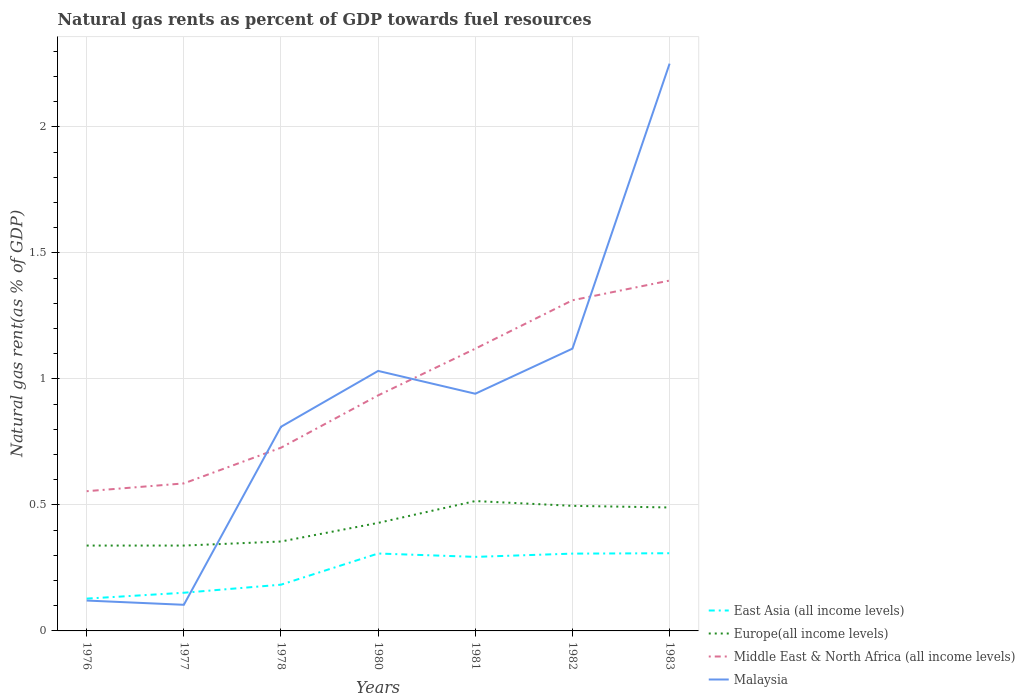Across all years, what is the maximum natural gas rent in East Asia (all income levels)?
Keep it short and to the point. 0.13. What is the total natural gas rent in Europe(all income levels) in the graph?
Ensure brevity in your answer.  0.03. What is the difference between the highest and the second highest natural gas rent in Malaysia?
Ensure brevity in your answer.  2.15. How many years are there in the graph?
Make the answer very short. 7. What is the difference between two consecutive major ticks on the Y-axis?
Keep it short and to the point. 0.5. Where does the legend appear in the graph?
Offer a very short reply. Bottom right. How many legend labels are there?
Your answer should be very brief. 4. How are the legend labels stacked?
Your answer should be compact. Vertical. What is the title of the graph?
Provide a succinct answer. Natural gas rents as percent of GDP towards fuel resources. What is the label or title of the X-axis?
Provide a succinct answer. Years. What is the label or title of the Y-axis?
Provide a short and direct response. Natural gas rent(as % of GDP). What is the Natural gas rent(as % of GDP) of East Asia (all income levels) in 1976?
Your answer should be very brief. 0.13. What is the Natural gas rent(as % of GDP) in Europe(all income levels) in 1976?
Your response must be concise. 0.34. What is the Natural gas rent(as % of GDP) of Middle East & North Africa (all income levels) in 1976?
Offer a very short reply. 0.55. What is the Natural gas rent(as % of GDP) in Malaysia in 1976?
Offer a very short reply. 0.12. What is the Natural gas rent(as % of GDP) in East Asia (all income levels) in 1977?
Your answer should be compact. 0.15. What is the Natural gas rent(as % of GDP) of Europe(all income levels) in 1977?
Give a very brief answer. 0.34. What is the Natural gas rent(as % of GDP) in Middle East & North Africa (all income levels) in 1977?
Your answer should be very brief. 0.59. What is the Natural gas rent(as % of GDP) of Malaysia in 1977?
Offer a very short reply. 0.1. What is the Natural gas rent(as % of GDP) in East Asia (all income levels) in 1978?
Offer a very short reply. 0.18. What is the Natural gas rent(as % of GDP) in Europe(all income levels) in 1978?
Your answer should be compact. 0.35. What is the Natural gas rent(as % of GDP) in Middle East & North Africa (all income levels) in 1978?
Provide a succinct answer. 0.73. What is the Natural gas rent(as % of GDP) in Malaysia in 1978?
Your answer should be compact. 0.81. What is the Natural gas rent(as % of GDP) in East Asia (all income levels) in 1980?
Your response must be concise. 0.31. What is the Natural gas rent(as % of GDP) of Europe(all income levels) in 1980?
Give a very brief answer. 0.43. What is the Natural gas rent(as % of GDP) in Middle East & North Africa (all income levels) in 1980?
Make the answer very short. 0.93. What is the Natural gas rent(as % of GDP) of Malaysia in 1980?
Give a very brief answer. 1.03. What is the Natural gas rent(as % of GDP) in East Asia (all income levels) in 1981?
Ensure brevity in your answer.  0.29. What is the Natural gas rent(as % of GDP) in Europe(all income levels) in 1981?
Your answer should be compact. 0.52. What is the Natural gas rent(as % of GDP) of Middle East & North Africa (all income levels) in 1981?
Your answer should be compact. 1.12. What is the Natural gas rent(as % of GDP) of Malaysia in 1981?
Offer a terse response. 0.94. What is the Natural gas rent(as % of GDP) of East Asia (all income levels) in 1982?
Ensure brevity in your answer.  0.31. What is the Natural gas rent(as % of GDP) of Europe(all income levels) in 1982?
Offer a very short reply. 0.5. What is the Natural gas rent(as % of GDP) in Middle East & North Africa (all income levels) in 1982?
Offer a terse response. 1.31. What is the Natural gas rent(as % of GDP) in Malaysia in 1982?
Your answer should be compact. 1.12. What is the Natural gas rent(as % of GDP) in East Asia (all income levels) in 1983?
Give a very brief answer. 0.31. What is the Natural gas rent(as % of GDP) in Europe(all income levels) in 1983?
Offer a very short reply. 0.49. What is the Natural gas rent(as % of GDP) in Middle East & North Africa (all income levels) in 1983?
Offer a very short reply. 1.39. What is the Natural gas rent(as % of GDP) of Malaysia in 1983?
Provide a short and direct response. 2.25. Across all years, what is the maximum Natural gas rent(as % of GDP) of East Asia (all income levels)?
Keep it short and to the point. 0.31. Across all years, what is the maximum Natural gas rent(as % of GDP) in Europe(all income levels)?
Offer a very short reply. 0.52. Across all years, what is the maximum Natural gas rent(as % of GDP) of Middle East & North Africa (all income levels)?
Provide a short and direct response. 1.39. Across all years, what is the maximum Natural gas rent(as % of GDP) of Malaysia?
Ensure brevity in your answer.  2.25. Across all years, what is the minimum Natural gas rent(as % of GDP) of East Asia (all income levels)?
Give a very brief answer. 0.13. Across all years, what is the minimum Natural gas rent(as % of GDP) in Europe(all income levels)?
Your answer should be very brief. 0.34. Across all years, what is the minimum Natural gas rent(as % of GDP) of Middle East & North Africa (all income levels)?
Offer a very short reply. 0.55. Across all years, what is the minimum Natural gas rent(as % of GDP) in Malaysia?
Offer a very short reply. 0.1. What is the total Natural gas rent(as % of GDP) of East Asia (all income levels) in the graph?
Give a very brief answer. 1.68. What is the total Natural gas rent(as % of GDP) of Europe(all income levels) in the graph?
Provide a short and direct response. 2.96. What is the total Natural gas rent(as % of GDP) in Middle East & North Africa (all income levels) in the graph?
Your answer should be very brief. 6.62. What is the total Natural gas rent(as % of GDP) in Malaysia in the graph?
Give a very brief answer. 6.38. What is the difference between the Natural gas rent(as % of GDP) of East Asia (all income levels) in 1976 and that in 1977?
Give a very brief answer. -0.02. What is the difference between the Natural gas rent(as % of GDP) in Europe(all income levels) in 1976 and that in 1977?
Provide a succinct answer. -0. What is the difference between the Natural gas rent(as % of GDP) in Middle East & North Africa (all income levels) in 1976 and that in 1977?
Provide a succinct answer. -0.03. What is the difference between the Natural gas rent(as % of GDP) of Malaysia in 1976 and that in 1977?
Offer a very short reply. 0.02. What is the difference between the Natural gas rent(as % of GDP) in East Asia (all income levels) in 1976 and that in 1978?
Provide a short and direct response. -0.06. What is the difference between the Natural gas rent(as % of GDP) of Europe(all income levels) in 1976 and that in 1978?
Give a very brief answer. -0.02. What is the difference between the Natural gas rent(as % of GDP) in Middle East & North Africa (all income levels) in 1976 and that in 1978?
Your answer should be compact. -0.17. What is the difference between the Natural gas rent(as % of GDP) of Malaysia in 1976 and that in 1978?
Give a very brief answer. -0.69. What is the difference between the Natural gas rent(as % of GDP) in East Asia (all income levels) in 1976 and that in 1980?
Make the answer very short. -0.18. What is the difference between the Natural gas rent(as % of GDP) of Europe(all income levels) in 1976 and that in 1980?
Keep it short and to the point. -0.09. What is the difference between the Natural gas rent(as % of GDP) of Middle East & North Africa (all income levels) in 1976 and that in 1980?
Provide a short and direct response. -0.38. What is the difference between the Natural gas rent(as % of GDP) in Malaysia in 1976 and that in 1980?
Offer a terse response. -0.91. What is the difference between the Natural gas rent(as % of GDP) of East Asia (all income levels) in 1976 and that in 1981?
Make the answer very short. -0.17. What is the difference between the Natural gas rent(as % of GDP) of Europe(all income levels) in 1976 and that in 1981?
Ensure brevity in your answer.  -0.18. What is the difference between the Natural gas rent(as % of GDP) of Middle East & North Africa (all income levels) in 1976 and that in 1981?
Give a very brief answer. -0.57. What is the difference between the Natural gas rent(as % of GDP) in Malaysia in 1976 and that in 1981?
Your response must be concise. -0.82. What is the difference between the Natural gas rent(as % of GDP) in East Asia (all income levels) in 1976 and that in 1982?
Make the answer very short. -0.18. What is the difference between the Natural gas rent(as % of GDP) of Europe(all income levels) in 1976 and that in 1982?
Offer a terse response. -0.16. What is the difference between the Natural gas rent(as % of GDP) in Middle East & North Africa (all income levels) in 1976 and that in 1982?
Make the answer very short. -0.76. What is the difference between the Natural gas rent(as % of GDP) of Malaysia in 1976 and that in 1982?
Provide a succinct answer. -1. What is the difference between the Natural gas rent(as % of GDP) in East Asia (all income levels) in 1976 and that in 1983?
Your answer should be compact. -0.18. What is the difference between the Natural gas rent(as % of GDP) of Europe(all income levels) in 1976 and that in 1983?
Your answer should be very brief. -0.15. What is the difference between the Natural gas rent(as % of GDP) in Middle East & North Africa (all income levels) in 1976 and that in 1983?
Provide a succinct answer. -0.84. What is the difference between the Natural gas rent(as % of GDP) of Malaysia in 1976 and that in 1983?
Provide a short and direct response. -2.13. What is the difference between the Natural gas rent(as % of GDP) in East Asia (all income levels) in 1977 and that in 1978?
Provide a succinct answer. -0.03. What is the difference between the Natural gas rent(as % of GDP) of Europe(all income levels) in 1977 and that in 1978?
Your answer should be very brief. -0.02. What is the difference between the Natural gas rent(as % of GDP) of Middle East & North Africa (all income levels) in 1977 and that in 1978?
Your answer should be very brief. -0.14. What is the difference between the Natural gas rent(as % of GDP) of Malaysia in 1977 and that in 1978?
Make the answer very short. -0.71. What is the difference between the Natural gas rent(as % of GDP) in East Asia (all income levels) in 1977 and that in 1980?
Keep it short and to the point. -0.16. What is the difference between the Natural gas rent(as % of GDP) of Europe(all income levels) in 1977 and that in 1980?
Provide a short and direct response. -0.09. What is the difference between the Natural gas rent(as % of GDP) of Middle East & North Africa (all income levels) in 1977 and that in 1980?
Ensure brevity in your answer.  -0.35. What is the difference between the Natural gas rent(as % of GDP) in Malaysia in 1977 and that in 1980?
Offer a very short reply. -0.93. What is the difference between the Natural gas rent(as % of GDP) of East Asia (all income levels) in 1977 and that in 1981?
Give a very brief answer. -0.14. What is the difference between the Natural gas rent(as % of GDP) of Europe(all income levels) in 1977 and that in 1981?
Provide a short and direct response. -0.18. What is the difference between the Natural gas rent(as % of GDP) in Middle East & North Africa (all income levels) in 1977 and that in 1981?
Your answer should be very brief. -0.53. What is the difference between the Natural gas rent(as % of GDP) of Malaysia in 1977 and that in 1981?
Offer a very short reply. -0.84. What is the difference between the Natural gas rent(as % of GDP) of East Asia (all income levels) in 1977 and that in 1982?
Provide a short and direct response. -0.16. What is the difference between the Natural gas rent(as % of GDP) of Europe(all income levels) in 1977 and that in 1982?
Your answer should be very brief. -0.16. What is the difference between the Natural gas rent(as % of GDP) in Middle East & North Africa (all income levels) in 1977 and that in 1982?
Your answer should be compact. -0.73. What is the difference between the Natural gas rent(as % of GDP) in Malaysia in 1977 and that in 1982?
Offer a terse response. -1.02. What is the difference between the Natural gas rent(as % of GDP) in East Asia (all income levels) in 1977 and that in 1983?
Provide a succinct answer. -0.16. What is the difference between the Natural gas rent(as % of GDP) in Europe(all income levels) in 1977 and that in 1983?
Give a very brief answer. -0.15. What is the difference between the Natural gas rent(as % of GDP) in Middle East & North Africa (all income levels) in 1977 and that in 1983?
Offer a terse response. -0.8. What is the difference between the Natural gas rent(as % of GDP) of Malaysia in 1977 and that in 1983?
Offer a terse response. -2.15. What is the difference between the Natural gas rent(as % of GDP) in East Asia (all income levels) in 1978 and that in 1980?
Your answer should be very brief. -0.12. What is the difference between the Natural gas rent(as % of GDP) of Europe(all income levels) in 1978 and that in 1980?
Provide a succinct answer. -0.07. What is the difference between the Natural gas rent(as % of GDP) of Middle East & North Africa (all income levels) in 1978 and that in 1980?
Make the answer very short. -0.21. What is the difference between the Natural gas rent(as % of GDP) in Malaysia in 1978 and that in 1980?
Provide a short and direct response. -0.22. What is the difference between the Natural gas rent(as % of GDP) in East Asia (all income levels) in 1978 and that in 1981?
Offer a very short reply. -0.11. What is the difference between the Natural gas rent(as % of GDP) in Europe(all income levels) in 1978 and that in 1981?
Your answer should be very brief. -0.16. What is the difference between the Natural gas rent(as % of GDP) of Middle East & North Africa (all income levels) in 1978 and that in 1981?
Offer a very short reply. -0.39. What is the difference between the Natural gas rent(as % of GDP) of Malaysia in 1978 and that in 1981?
Offer a very short reply. -0.13. What is the difference between the Natural gas rent(as % of GDP) of East Asia (all income levels) in 1978 and that in 1982?
Keep it short and to the point. -0.12. What is the difference between the Natural gas rent(as % of GDP) of Europe(all income levels) in 1978 and that in 1982?
Your answer should be very brief. -0.14. What is the difference between the Natural gas rent(as % of GDP) of Middle East & North Africa (all income levels) in 1978 and that in 1982?
Keep it short and to the point. -0.58. What is the difference between the Natural gas rent(as % of GDP) in Malaysia in 1978 and that in 1982?
Ensure brevity in your answer.  -0.31. What is the difference between the Natural gas rent(as % of GDP) of East Asia (all income levels) in 1978 and that in 1983?
Your answer should be very brief. -0.12. What is the difference between the Natural gas rent(as % of GDP) of Europe(all income levels) in 1978 and that in 1983?
Your answer should be very brief. -0.14. What is the difference between the Natural gas rent(as % of GDP) of Middle East & North Africa (all income levels) in 1978 and that in 1983?
Your response must be concise. -0.66. What is the difference between the Natural gas rent(as % of GDP) of Malaysia in 1978 and that in 1983?
Offer a terse response. -1.44. What is the difference between the Natural gas rent(as % of GDP) of East Asia (all income levels) in 1980 and that in 1981?
Your answer should be compact. 0.01. What is the difference between the Natural gas rent(as % of GDP) in Europe(all income levels) in 1980 and that in 1981?
Ensure brevity in your answer.  -0.09. What is the difference between the Natural gas rent(as % of GDP) in Middle East & North Africa (all income levels) in 1980 and that in 1981?
Ensure brevity in your answer.  -0.19. What is the difference between the Natural gas rent(as % of GDP) of Malaysia in 1980 and that in 1981?
Your answer should be very brief. 0.09. What is the difference between the Natural gas rent(as % of GDP) in East Asia (all income levels) in 1980 and that in 1982?
Offer a terse response. 0. What is the difference between the Natural gas rent(as % of GDP) in Europe(all income levels) in 1980 and that in 1982?
Your answer should be compact. -0.07. What is the difference between the Natural gas rent(as % of GDP) in Middle East & North Africa (all income levels) in 1980 and that in 1982?
Your response must be concise. -0.38. What is the difference between the Natural gas rent(as % of GDP) in Malaysia in 1980 and that in 1982?
Your answer should be very brief. -0.09. What is the difference between the Natural gas rent(as % of GDP) of East Asia (all income levels) in 1980 and that in 1983?
Make the answer very short. -0. What is the difference between the Natural gas rent(as % of GDP) in Europe(all income levels) in 1980 and that in 1983?
Your response must be concise. -0.06. What is the difference between the Natural gas rent(as % of GDP) of Middle East & North Africa (all income levels) in 1980 and that in 1983?
Give a very brief answer. -0.46. What is the difference between the Natural gas rent(as % of GDP) in Malaysia in 1980 and that in 1983?
Your answer should be compact. -1.22. What is the difference between the Natural gas rent(as % of GDP) in East Asia (all income levels) in 1981 and that in 1982?
Offer a very short reply. -0.01. What is the difference between the Natural gas rent(as % of GDP) in Europe(all income levels) in 1981 and that in 1982?
Ensure brevity in your answer.  0.02. What is the difference between the Natural gas rent(as % of GDP) of Middle East & North Africa (all income levels) in 1981 and that in 1982?
Your answer should be compact. -0.19. What is the difference between the Natural gas rent(as % of GDP) of Malaysia in 1981 and that in 1982?
Offer a very short reply. -0.18. What is the difference between the Natural gas rent(as % of GDP) in East Asia (all income levels) in 1981 and that in 1983?
Your answer should be very brief. -0.01. What is the difference between the Natural gas rent(as % of GDP) of Europe(all income levels) in 1981 and that in 1983?
Your answer should be very brief. 0.03. What is the difference between the Natural gas rent(as % of GDP) in Middle East & North Africa (all income levels) in 1981 and that in 1983?
Your answer should be compact. -0.27. What is the difference between the Natural gas rent(as % of GDP) in Malaysia in 1981 and that in 1983?
Provide a succinct answer. -1.31. What is the difference between the Natural gas rent(as % of GDP) in East Asia (all income levels) in 1982 and that in 1983?
Provide a succinct answer. -0. What is the difference between the Natural gas rent(as % of GDP) in Europe(all income levels) in 1982 and that in 1983?
Keep it short and to the point. 0.01. What is the difference between the Natural gas rent(as % of GDP) in Middle East & North Africa (all income levels) in 1982 and that in 1983?
Your response must be concise. -0.08. What is the difference between the Natural gas rent(as % of GDP) of Malaysia in 1982 and that in 1983?
Give a very brief answer. -1.13. What is the difference between the Natural gas rent(as % of GDP) of East Asia (all income levels) in 1976 and the Natural gas rent(as % of GDP) of Europe(all income levels) in 1977?
Your response must be concise. -0.21. What is the difference between the Natural gas rent(as % of GDP) in East Asia (all income levels) in 1976 and the Natural gas rent(as % of GDP) in Middle East & North Africa (all income levels) in 1977?
Offer a very short reply. -0.46. What is the difference between the Natural gas rent(as % of GDP) of East Asia (all income levels) in 1976 and the Natural gas rent(as % of GDP) of Malaysia in 1977?
Your response must be concise. 0.02. What is the difference between the Natural gas rent(as % of GDP) of Europe(all income levels) in 1976 and the Natural gas rent(as % of GDP) of Middle East & North Africa (all income levels) in 1977?
Your answer should be compact. -0.25. What is the difference between the Natural gas rent(as % of GDP) in Europe(all income levels) in 1976 and the Natural gas rent(as % of GDP) in Malaysia in 1977?
Provide a succinct answer. 0.23. What is the difference between the Natural gas rent(as % of GDP) in Middle East & North Africa (all income levels) in 1976 and the Natural gas rent(as % of GDP) in Malaysia in 1977?
Your answer should be very brief. 0.45. What is the difference between the Natural gas rent(as % of GDP) of East Asia (all income levels) in 1976 and the Natural gas rent(as % of GDP) of Europe(all income levels) in 1978?
Make the answer very short. -0.23. What is the difference between the Natural gas rent(as % of GDP) in East Asia (all income levels) in 1976 and the Natural gas rent(as % of GDP) in Middle East & North Africa (all income levels) in 1978?
Ensure brevity in your answer.  -0.6. What is the difference between the Natural gas rent(as % of GDP) of East Asia (all income levels) in 1976 and the Natural gas rent(as % of GDP) of Malaysia in 1978?
Your response must be concise. -0.68. What is the difference between the Natural gas rent(as % of GDP) in Europe(all income levels) in 1976 and the Natural gas rent(as % of GDP) in Middle East & North Africa (all income levels) in 1978?
Your answer should be compact. -0.39. What is the difference between the Natural gas rent(as % of GDP) in Europe(all income levels) in 1976 and the Natural gas rent(as % of GDP) in Malaysia in 1978?
Offer a terse response. -0.47. What is the difference between the Natural gas rent(as % of GDP) of Middle East & North Africa (all income levels) in 1976 and the Natural gas rent(as % of GDP) of Malaysia in 1978?
Offer a very short reply. -0.26. What is the difference between the Natural gas rent(as % of GDP) of East Asia (all income levels) in 1976 and the Natural gas rent(as % of GDP) of Europe(all income levels) in 1980?
Your answer should be compact. -0.3. What is the difference between the Natural gas rent(as % of GDP) in East Asia (all income levels) in 1976 and the Natural gas rent(as % of GDP) in Middle East & North Africa (all income levels) in 1980?
Ensure brevity in your answer.  -0.81. What is the difference between the Natural gas rent(as % of GDP) in East Asia (all income levels) in 1976 and the Natural gas rent(as % of GDP) in Malaysia in 1980?
Offer a very short reply. -0.9. What is the difference between the Natural gas rent(as % of GDP) of Europe(all income levels) in 1976 and the Natural gas rent(as % of GDP) of Middle East & North Africa (all income levels) in 1980?
Offer a very short reply. -0.6. What is the difference between the Natural gas rent(as % of GDP) in Europe(all income levels) in 1976 and the Natural gas rent(as % of GDP) in Malaysia in 1980?
Your answer should be compact. -0.69. What is the difference between the Natural gas rent(as % of GDP) of Middle East & North Africa (all income levels) in 1976 and the Natural gas rent(as % of GDP) of Malaysia in 1980?
Make the answer very short. -0.48. What is the difference between the Natural gas rent(as % of GDP) of East Asia (all income levels) in 1976 and the Natural gas rent(as % of GDP) of Europe(all income levels) in 1981?
Keep it short and to the point. -0.39. What is the difference between the Natural gas rent(as % of GDP) in East Asia (all income levels) in 1976 and the Natural gas rent(as % of GDP) in Middle East & North Africa (all income levels) in 1981?
Offer a terse response. -0.99. What is the difference between the Natural gas rent(as % of GDP) of East Asia (all income levels) in 1976 and the Natural gas rent(as % of GDP) of Malaysia in 1981?
Provide a short and direct response. -0.81. What is the difference between the Natural gas rent(as % of GDP) in Europe(all income levels) in 1976 and the Natural gas rent(as % of GDP) in Middle East & North Africa (all income levels) in 1981?
Provide a succinct answer. -0.78. What is the difference between the Natural gas rent(as % of GDP) of Europe(all income levels) in 1976 and the Natural gas rent(as % of GDP) of Malaysia in 1981?
Your answer should be compact. -0.6. What is the difference between the Natural gas rent(as % of GDP) in Middle East & North Africa (all income levels) in 1976 and the Natural gas rent(as % of GDP) in Malaysia in 1981?
Provide a short and direct response. -0.39. What is the difference between the Natural gas rent(as % of GDP) in East Asia (all income levels) in 1976 and the Natural gas rent(as % of GDP) in Europe(all income levels) in 1982?
Give a very brief answer. -0.37. What is the difference between the Natural gas rent(as % of GDP) of East Asia (all income levels) in 1976 and the Natural gas rent(as % of GDP) of Middle East & North Africa (all income levels) in 1982?
Your answer should be compact. -1.18. What is the difference between the Natural gas rent(as % of GDP) of East Asia (all income levels) in 1976 and the Natural gas rent(as % of GDP) of Malaysia in 1982?
Provide a succinct answer. -0.99. What is the difference between the Natural gas rent(as % of GDP) of Europe(all income levels) in 1976 and the Natural gas rent(as % of GDP) of Middle East & North Africa (all income levels) in 1982?
Your answer should be very brief. -0.97. What is the difference between the Natural gas rent(as % of GDP) in Europe(all income levels) in 1976 and the Natural gas rent(as % of GDP) in Malaysia in 1982?
Offer a terse response. -0.78. What is the difference between the Natural gas rent(as % of GDP) in Middle East & North Africa (all income levels) in 1976 and the Natural gas rent(as % of GDP) in Malaysia in 1982?
Keep it short and to the point. -0.57. What is the difference between the Natural gas rent(as % of GDP) in East Asia (all income levels) in 1976 and the Natural gas rent(as % of GDP) in Europe(all income levels) in 1983?
Provide a succinct answer. -0.36. What is the difference between the Natural gas rent(as % of GDP) of East Asia (all income levels) in 1976 and the Natural gas rent(as % of GDP) of Middle East & North Africa (all income levels) in 1983?
Provide a short and direct response. -1.26. What is the difference between the Natural gas rent(as % of GDP) of East Asia (all income levels) in 1976 and the Natural gas rent(as % of GDP) of Malaysia in 1983?
Your answer should be compact. -2.12. What is the difference between the Natural gas rent(as % of GDP) of Europe(all income levels) in 1976 and the Natural gas rent(as % of GDP) of Middle East & North Africa (all income levels) in 1983?
Offer a very short reply. -1.05. What is the difference between the Natural gas rent(as % of GDP) of Europe(all income levels) in 1976 and the Natural gas rent(as % of GDP) of Malaysia in 1983?
Your answer should be very brief. -1.91. What is the difference between the Natural gas rent(as % of GDP) of Middle East & North Africa (all income levels) in 1976 and the Natural gas rent(as % of GDP) of Malaysia in 1983?
Provide a succinct answer. -1.7. What is the difference between the Natural gas rent(as % of GDP) in East Asia (all income levels) in 1977 and the Natural gas rent(as % of GDP) in Europe(all income levels) in 1978?
Keep it short and to the point. -0.2. What is the difference between the Natural gas rent(as % of GDP) of East Asia (all income levels) in 1977 and the Natural gas rent(as % of GDP) of Middle East & North Africa (all income levels) in 1978?
Make the answer very short. -0.58. What is the difference between the Natural gas rent(as % of GDP) of East Asia (all income levels) in 1977 and the Natural gas rent(as % of GDP) of Malaysia in 1978?
Offer a terse response. -0.66. What is the difference between the Natural gas rent(as % of GDP) in Europe(all income levels) in 1977 and the Natural gas rent(as % of GDP) in Middle East & North Africa (all income levels) in 1978?
Give a very brief answer. -0.39. What is the difference between the Natural gas rent(as % of GDP) of Europe(all income levels) in 1977 and the Natural gas rent(as % of GDP) of Malaysia in 1978?
Keep it short and to the point. -0.47. What is the difference between the Natural gas rent(as % of GDP) of Middle East & North Africa (all income levels) in 1977 and the Natural gas rent(as % of GDP) of Malaysia in 1978?
Provide a succinct answer. -0.22. What is the difference between the Natural gas rent(as % of GDP) in East Asia (all income levels) in 1977 and the Natural gas rent(as % of GDP) in Europe(all income levels) in 1980?
Your answer should be very brief. -0.28. What is the difference between the Natural gas rent(as % of GDP) in East Asia (all income levels) in 1977 and the Natural gas rent(as % of GDP) in Middle East & North Africa (all income levels) in 1980?
Your answer should be very brief. -0.78. What is the difference between the Natural gas rent(as % of GDP) of East Asia (all income levels) in 1977 and the Natural gas rent(as % of GDP) of Malaysia in 1980?
Make the answer very short. -0.88. What is the difference between the Natural gas rent(as % of GDP) of Europe(all income levels) in 1977 and the Natural gas rent(as % of GDP) of Middle East & North Africa (all income levels) in 1980?
Ensure brevity in your answer.  -0.6. What is the difference between the Natural gas rent(as % of GDP) in Europe(all income levels) in 1977 and the Natural gas rent(as % of GDP) in Malaysia in 1980?
Your answer should be compact. -0.69. What is the difference between the Natural gas rent(as % of GDP) in Middle East & North Africa (all income levels) in 1977 and the Natural gas rent(as % of GDP) in Malaysia in 1980?
Give a very brief answer. -0.45. What is the difference between the Natural gas rent(as % of GDP) in East Asia (all income levels) in 1977 and the Natural gas rent(as % of GDP) in Europe(all income levels) in 1981?
Make the answer very short. -0.36. What is the difference between the Natural gas rent(as % of GDP) of East Asia (all income levels) in 1977 and the Natural gas rent(as % of GDP) of Middle East & North Africa (all income levels) in 1981?
Your answer should be very brief. -0.97. What is the difference between the Natural gas rent(as % of GDP) of East Asia (all income levels) in 1977 and the Natural gas rent(as % of GDP) of Malaysia in 1981?
Provide a succinct answer. -0.79. What is the difference between the Natural gas rent(as % of GDP) of Europe(all income levels) in 1977 and the Natural gas rent(as % of GDP) of Middle East & North Africa (all income levels) in 1981?
Ensure brevity in your answer.  -0.78. What is the difference between the Natural gas rent(as % of GDP) in Europe(all income levels) in 1977 and the Natural gas rent(as % of GDP) in Malaysia in 1981?
Offer a terse response. -0.6. What is the difference between the Natural gas rent(as % of GDP) of Middle East & North Africa (all income levels) in 1977 and the Natural gas rent(as % of GDP) of Malaysia in 1981?
Give a very brief answer. -0.36. What is the difference between the Natural gas rent(as % of GDP) in East Asia (all income levels) in 1977 and the Natural gas rent(as % of GDP) in Europe(all income levels) in 1982?
Your answer should be very brief. -0.34. What is the difference between the Natural gas rent(as % of GDP) of East Asia (all income levels) in 1977 and the Natural gas rent(as % of GDP) of Middle East & North Africa (all income levels) in 1982?
Offer a very short reply. -1.16. What is the difference between the Natural gas rent(as % of GDP) of East Asia (all income levels) in 1977 and the Natural gas rent(as % of GDP) of Malaysia in 1982?
Provide a succinct answer. -0.97. What is the difference between the Natural gas rent(as % of GDP) in Europe(all income levels) in 1977 and the Natural gas rent(as % of GDP) in Middle East & North Africa (all income levels) in 1982?
Offer a terse response. -0.97. What is the difference between the Natural gas rent(as % of GDP) in Europe(all income levels) in 1977 and the Natural gas rent(as % of GDP) in Malaysia in 1982?
Your response must be concise. -0.78. What is the difference between the Natural gas rent(as % of GDP) in Middle East & North Africa (all income levels) in 1977 and the Natural gas rent(as % of GDP) in Malaysia in 1982?
Your answer should be compact. -0.53. What is the difference between the Natural gas rent(as % of GDP) in East Asia (all income levels) in 1977 and the Natural gas rent(as % of GDP) in Europe(all income levels) in 1983?
Give a very brief answer. -0.34. What is the difference between the Natural gas rent(as % of GDP) in East Asia (all income levels) in 1977 and the Natural gas rent(as % of GDP) in Middle East & North Africa (all income levels) in 1983?
Ensure brevity in your answer.  -1.24. What is the difference between the Natural gas rent(as % of GDP) in East Asia (all income levels) in 1977 and the Natural gas rent(as % of GDP) in Malaysia in 1983?
Give a very brief answer. -2.1. What is the difference between the Natural gas rent(as % of GDP) in Europe(all income levels) in 1977 and the Natural gas rent(as % of GDP) in Middle East & North Africa (all income levels) in 1983?
Offer a terse response. -1.05. What is the difference between the Natural gas rent(as % of GDP) of Europe(all income levels) in 1977 and the Natural gas rent(as % of GDP) of Malaysia in 1983?
Your answer should be compact. -1.91. What is the difference between the Natural gas rent(as % of GDP) of Middle East & North Africa (all income levels) in 1977 and the Natural gas rent(as % of GDP) of Malaysia in 1983?
Give a very brief answer. -1.67. What is the difference between the Natural gas rent(as % of GDP) in East Asia (all income levels) in 1978 and the Natural gas rent(as % of GDP) in Europe(all income levels) in 1980?
Make the answer very short. -0.25. What is the difference between the Natural gas rent(as % of GDP) in East Asia (all income levels) in 1978 and the Natural gas rent(as % of GDP) in Middle East & North Africa (all income levels) in 1980?
Your answer should be compact. -0.75. What is the difference between the Natural gas rent(as % of GDP) of East Asia (all income levels) in 1978 and the Natural gas rent(as % of GDP) of Malaysia in 1980?
Ensure brevity in your answer.  -0.85. What is the difference between the Natural gas rent(as % of GDP) of Europe(all income levels) in 1978 and the Natural gas rent(as % of GDP) of Middle East & North Africa (all income levels) in 1980?
Provide a short and direct response. -0.58. What is the difference between the Natural gas rent(as % of GDP) of Europe(all income levels) in 1978 and the Natural gas rent(as % of GDP) of Malaysia in 1980?
Provide a short and direct response. -0.68. What is the difference between the Natural gas rent(as % of GDP) of Middle East & North Africa (all income levels) in 1978 and the Natural gas rent(as % of GDP) of Malaysia in 1980?
Offer a terse response. -0.3. What is the difference between the Natural gas rent(as % of GDP) of East Asia (all income levels) in 1978 and the Natural gas rent(as % of GDP) of Europe(all income levels) in 1981?
Provide a short and direct response. -0.33. What is the difference between the Natural gas rent(as % of GDP) in East Asia (all income levels) in 1978 and the Natural gas rent(as % of GDP) in Middle East & North Africa (all income levels) in 1981?
Make the answer very short. -0.94. What is the difference between the Natural gas rent(as % of GDP) in East Asia (all income levels) in 1978 and the Natural gas rent(as % of GDP) in Malaysia in 1981?
Your answer should be compact. -0.76. What is the difference between the Natural gas rent(as % of GDP) in Europe(all income levels) in 1978 and the Natural gas rent(as % of GDP) in Middle East & North Africa (all income levels) in 1981?
Your answer should be compact. -0.77. What is the difference between the Natural gas rent(as % of GDP) in Europe(all income levels) in 1978 and the Natural gas rent(as % of GDP) in Malaysia in 1981?
Provide a short and direct response. -0.59. What is the difference between the Natural gas rent(as % of GDP) of Middle East & North Africa (all income levels) in 1978 and the Natural gas rent(as % of GDP) of Malaysia in 1981?
Provide a short and direct response. -0.21. What is the difference between the Natural gas rent(as % of GDP) in East Asia (all income levels) in 1978 and the Natural gas rent(as % of GDP) in Europe(all income levels) in 1982?
Provide a short and direct response. -0.31. What is the difference between the Natural gas rent(as % of GDP) of East Asia (all income levels) in 1978 and the Natural gas rent(as % of GDP) of Middle East & North Africa (all income levels) in 1982?
Offer a very short reply. -1.13. What is the difference between the Natural gas rent(as % of GDP) of East Asia (all income levels) in 1978 and the Natural gas rent(as % of GDP) of Malaysia in 1982?
Make the answer very short. -0.94. What is the difference between the Natural gas rent(as % of GDP) in Europe(all income levels) in 1978 and the Natural gas rent(as % of GDP) in Middle East & North Africa (all income levels) in 1982?
Your answer should be very brief. -0.96. What is the difference between the Natural gas rent(as % of GDP) of Europe(all income levels) in 1978 and the Natural gas rent(as % of GDP) of Malaysia in 1982?
Keep it short and to the point. -0.77. What is the difference between the Natural gas rent(as % of GDP) in Middle East & North Africa (all income levels) in 1978 and the Natural gas rent(as % of GDP) in Malaysia in 1982?
Keep it short and to the point. -0.39. What is the difference between the Natural gas rent(as % of GDP) of East Asia (all income levels) in 1978 and the Natural gas rent(as % of GDP) of Europe(all income levels) in 1983?
Your answer should be compact. -0.31. What is the difference between the Natural gas rent(as % of GDP) in East Asia (all income levels) in 1978 and the Natural gas rent(as % of GDP) in Middle East & North Africa (all income levels) in 1983?
Offer a terse response. -1.21. What is the difference between the Natural gas rent(as % of GDP) in East Asia (all income levels) in 1978 and the Natural gas rent(as % of GDP) in Malaysia in 1983?
Offer a very short reply. -2.07. What is the difference between the Natural gas rent(as % of GDP) in Europe(all income levels) in 1978 and the Natural gas rent(as % of GDP) in Middle East & North Africa (all income levels) in 1983?
Your answer should be compact. -1.04. What is the difference between the Natural gas rent(as % of GDP) of Europe(all income levels) in 1978 and the Natural gas rent(as % of GDP) of Malaysia in 1983?
Your answer should be compact. -1.9. What is the difference between the Natural gas rent(as % of GDP) in Middle East & North Africa (all income levels) in 1978 and the Natural gas rent(as % of GDP) in Malaysia in 1983?
Make the answer very short. -1.52. What is the difference between the Natural gas rent(as % of GDP) in East Asia (all income levels) in 1980 and the Natural gas rent(as % of GDP) in Europe(all income levels) in 1981?
Provide a succinct answer. -0.21. What is the difference between the Natural gas rent(as % of GDP) of East Asia (all income levels) in 1980 and the Natural gas rent(as % of GDP) of Middle East & North Africa (all income levels) in 1981?
Provide a succinct answer. -0.81. What is the difference between the Natural gas rent(as % of GDP) of East Asia (all income levels) in 1980 and the Natural gas rent(as % of GDP) of Malaysia in 1981?
Your answer should be very brief. -0.63. What is the difference between the Natural gas rent(as % of GDP) in Europe(all income levels) in 1980 and the Natural gas rent(as % of GDP) in Middle East & North Africa (all income levels) in 1981?
Make the answer very short. -0.69. What is the difference between the Natural gas rent(as % of GDP) in Europe(all income levels) in 1980 and the Natural gas rent(as % of GDP) in Malaysia in 1981?
Ensure brevity in your answer.  -0.51. What is the difference between the Natural gas rent(as % of GDP) of Middle East & North Africa (all income levels) in 1980 and the Natural gas rent(as % of GDP) of Malaysia in 1981?
Your answer should be compact. -0.01. What is the difference between the Natural gas rent(as % of GDP) of East Asia (all income levels) in 1980 and the Natural gas rent(as % of GDP) of Europe(all income levels) in 1982?
Your answer should be compact. -0.19. What is the difference between the Natural gas rent(as % of GDP) of East Asia (all income levels) in 1980 and the Natural gas rent(as % of GDP) of Middle East & North Africa (all income levels) in 1982?
Make the answer very short. -1. What is the difference between the Natural gas rent(as % of GDP) in East Asia (all income levels) in 1980 and the Natural gas rent(as % of GDP) in Malaysia in 1982?
Your answer should be compact. -0.81. What is the difference between the Natural gas rent(as % of GDP) of Europe(all income levels) in 1980 and the Natural gas rent(as % of GDP) of Middle East & North Africa (all income levels) in 1982?
Your answer should be compact. -0.88. What is the difference between the Natural gas rent(as % of GDP) of Europe(all income levels) in 1980 and the Natural gas rent(as % of GDP) of Malaysia in 1982?
Provide a short and direct response. -0.69. What is the difference between the Natural gas rent(as % of GDP) in Middle East & North Africa (all income levels) in 1980 and the Natural gas rent(as % of GDP) in Malaysia in 1982?
Your answer should be compact. -0.19. What is the difference between the Natural gas rent(as % of GDP) of East Asia (all income levels) in 1980 and the Natural gas rent(as % of GDP) of Europe(all income levels) in 1983?
Give a very brief answer. -0.18. What is the difference between the Natural gas rent(as % of GDP) in East Asia (all income levels) in 1980 and the Natural gas rent(as % of GDP) in Middle East & North Africa (all income levels) in 1983?
Offer a terse response. -1.08. What is the difference between the Natural gas rent(as % of GDP) of East Asia (all income levels) in 1980 and the Natural gas rent(as % of GDP) of Malaysia in 1983?
Your response must be concise. -1.94. What is the difference between the Natural gas rent(as % of GDP) of Europe(all income levels) in 1980 and the Natural gas rent(as % of GDP) of Middle East & North Africa (all income levels) in 1983?
Provide a succinct answer. -0.96. What is the difference between the Natural gas rent(as % of GDP) of Europe(all income levels) in 1980 and the Natural gas rent(as % of GDP) of Malaysia in 1983?
Give a very brief answer. -1.82. What is the difference between the Natural gas rent(as % of GDP) of Middle East & North Africa (all income levels) in 1980 and the Natural gas rent(as % of GDP) of Malaysia in 1983?
Provide a short and direct response. -1.32. What is the difference between the Natural gas rent(as % of GDP) of East Asia (all income levels) in 1981 and the Natural gas rent(as % of GDP) of Europe(all income levels) in 1982?
Your answer should be very brief. -0.2. What is the difference between the Natural gas rent(as % of GDP) in East Asia (all income levels) in 1981 and the Natural gas rent(as % of GDP) in Middle East & North Africa (all income levels) in 1982?
Offer a very short reply. -1.02. What is the difference between the Natural gas rent(as % of GDP) in East Asia (all income levels) in 1981 and the Natural gas rent(as % of GDP) in Malaysia in 1982?
Provide a succinct answer. -0.83. What is the difference between the Natural gas rent(as % of GDP) of Europe(all income levels) in 1981 and the Natural gas rent(as % of GDP) of Middle East & North Africa (all income levels) in 1982?
Provide a succinct answer. -0.8. What is the difference between the Natural gas rent(as % of GDP) of Europe(all income levels) in 1981 and the Natural gas rent(as % of GDP) of Malaysia in 1982?
Your response must be concise. -0.6. What is the difference between the Natural gas rent(as % of GDP) of Middle East & North Africa (all income levels) in 1981 and the Natural gas rent(as % of GDP) of Malaysia in 1982?
Ensure brevity in your answer.  -0. What is the difference between the Natural gas rent(as % of GDP) of East Asia (all income levels) in 1981 and the Natural gas rent(as % of GDP) of Europe(all income levels) in 1983?
Make the answer very short. -0.2. What is the difference between the Natural gas rent(as % of GDP) of East Asia (all income levels) in 1981 and the Natural gas rent(as % of GDP) of Middle East & North Africa (all income levels) in 1983?
Offer a terse response. -1.1. What is the difference between the Natural gas rent(as % of GDP) of East Asia (all income levels) in 1981 and the Natural gas rent(as % of GDP) of Malaysia in 1983?
Your response must be concise. -1.96. What is the difference between the Natural gas rent(as % of GDP) in Europe(all income levels) in 1981 and the Natural gas rent(as % of GDP) in Middle East & North Africa (all income levels) in 1983?
Your response must be concise. -0.88. What is the difference between the Natural gas rent(as % of GDP) in Europe(all income levels) in 1981 and the Natural gas rent(as % of GDP) in Malaysia in 1983?
Give a very brief answer. -1.74. What is the difference between the Natural gas rent(as % of GDP) in Middle East & North Africa (all income levels) in 1981 and the Natural gas rent(as % of GDP) in Malaysia in 1983?
Give a very brief answer. -1.13. What is the difference between the Natural gas rent(as % of GDP) of East Asia (all income levels) in 1982 and the Natural gas rent(as % of GDP) of Europe(all income levels) in 1983?
Give a very brief answer. -0.18. What is the difference between the Natural gas rent(as % of GDP) of East Asia (all income levels) in 1982 and the Natural gas rent(as % of GDP) of Middle East & North Africa (all income levels) in 1983?
Ensure brevity in your answer.  -1.08. What is the difference between the Natural gas rent(as % of GDP) in East Asia (all income levels) in 1982 and the Natural gas rent(as % of GDP) in Malaysia in 1983?
Give a very brief answer. -1.94. What is the difference between the Natural gas rent(as % of GDP) of Europe(all income levels) in 1982 and the Natural gas rent(as % of GDP) of Middle East & North Africa (all income levels) in 1983?
Give a very brief answer. -0.89. What is the difference between the Natural gas rent(as % of GDP) of Europe(all income levels) in 1982 and the Natural gas rent(as % of GDP) of Malaysia in 1983?
Provide a succinct answer. -1.75. What is the difference between the Natural gas rent(as % of GDP) of Middle East & North Africa (all income levels) in 1982 and the Natural gas rent(as % of GDP) of Malaysia in 1983?
Provide a short and direct response. -0.94. What is the average Natural gas rent(as % of GDP) in East Asia (all income levels) per year?
Make the answer very short. 0.24. What is the average Natural gas rent(as % of GDP) of Europe(all income levels) per year?
Your response must be concise. 0.42. What is the average Natural gas rent(as % of GDP) of Middle East & North Africa (all income levels) per year?
Provide a succinct answer. 0.95. What is the average Natural gas rent(as % of GDP) in Malaysia per year?
Provide a succinct answer. 0.91. In the year 1976, what is the difference between the Natural gas rent(as % of GDP) in East Asia (all income levels) and Natural gas rent(as % of GDP) in Europe(all income levels)?
Your response must be concise. -0.21. In the year 1976, what is the difference between the Natural gas rent(as % of GDP) in East Asia (all income levels) and Natural gas rent(as % of GDP) in Middle East & North Africa (all income levels)?
Your answer should be compact. -0.43. In the year 1976, what is the difference between the Natural gas rent(as % of GDP) in East Asia (all income levels) and Natural gas rent(as % of GDP) in Malaysia?
Offer a terse response. 0.01. In the year 1976, what is the difference between the Natural gas rent(as % of GDP) in Europe(all income levels) and Natural gas rent(as % of GDP) in Middle East & North Africa (all income levels)?
Ensure brevity in your answer.  -0.22. In the year 1976, what is the difference between the Natural gas rent(as % of GDP) of Europe(all income levels) and Natural gas rent(as % of GDP) of Malaysia?
Your answer should be very brief. 0.22. In the year 1976, what is the difference between the Natural gas rent(as % of GDP) of Middle East & North Africa (all income levels) and Natural gas rent(as % of GDP) of Malaysia?
Your response must be concise. 0.43. In the year 1977, what is the difference between the Natural gas rent(as % of GDP) in East Asia (all income levels) and Natural gas rent(as % of GDP) in Europe(all income levels)?
Provide a short and direct response. -0.19. In the year 1977, what is the difference between the Natural gas rent(as % of GDP) of East Asia (all income levels) and Natural gas rent(as % of GDP) of Middle East & North Africa (all income levels)?
Keep it short and to the point. -0.43. In the year 1977, what is the difference between the Natural gas rent(as % of GDP) in East Asia (all income levels) and Natural gas rent(as % of GDP) in Malaysia?
Provide a succinct answer. 0.05. In the year 1977, what is the difference between the Natural gas rent(as % of GDP) of Europe(all income levels) and Natural gas rent(as % of GDP) of Middle East & North Africa (all income levels)?
Give a very brief answer. -0.25. In the year 1977, what is the difference between the Natural gas rent(as % of GDP) of Europe(all income levels) and Natural gas rent(as % of GDP) of Malaysia?
Ensure brevity in your answer.  0.23. In the year 1977, what is the difference between the Natural gas rent(as % of GDP) in Middle East & North Africa (all income levels) and Natural gas rent(as % of GDP) in Malaysia?
Make the answer very short. 0.48. In the year 1978, what is the difference between the Natural gas rent(as % of GDP) of East Asia (all income levels) and Natural gas rent(as % of GDP) of Europe(all income levels)?
Give a very brief answer. -0.17. In the year 1978, what is the difference between the Natural gas rent(as % of GDP) in East Asia (all income levels) and Natural gas rent(as % of GDP) in Middle East & North Africa (all income levels)?
Your response must be concise. -0.54. In the year 1978, what is the difference between the Natural gas rent(as % of GDP) of East Asia (all income levels) and Natural gas rent(as % of GDP) of Malaysia?
Your answer should be compact. -0.63. In the year 1978, what is the difference between the Natural gas rent(as % of GDP) in Europe(all income levels) and Natural gas rent(as % of GDP) in Middle East & North Africa (all income levels)?
Ensure brevity in your answer.  -0.37. In the year 1978, what is the difference between the Natural gas rent(as % of GDP) of Europe(all income levels) and Natural gas rent(as % of GDP) of Malaysia?
Provide a succinct answer. -0.46. In the year 1978, what is the difference between the Natural gas rent(as % of GDP) of Middle East & North Africa (all income levels) and Natural gas rent(as % of GDP) of Malaysia?
Provide a short and direct response. -0.08. In the year 1980, what is the difference between the Natural gas rent(as % of GDP) in East Asia (all income levels) and Natural gas rent(as % of GDP) in Europe(all income levels)?
Ensure brevity in your answer.  -0.12. In the year 1980, what is the difference between the Natural gas rent(as % of GDP) of East Asia (all income levels) and Natural gas rent(as % of GDP) of Middle East & North Africa (all income levels)?
Your answer should be very brief. -0.63. In the year 1980, what is the difference between the Natural gas rent(as % of GDP) of East Asia (all income levels) and Natural gas rent(as % of GDP) of Malaysia?
Offer a very short reply. -0.72. In the year 1980, what is the difference between the Natural gas rent(as % of GDP) of Europe(all income levels) and Natural gas rent(as % of GDP) of Middle East & North Africa (all income levels)?
Make the answer very short. -0.51. In the year 1980, what is the difference between the Natural gas rent(as % of GDP) in Europe(all income levels) and Natural gas rent(as % of GDP) in Malaysia?
Make the answer very short. -0.6. In the year 1980, what is the difference between the Natural gas rent(as % of GDP) of Middle East & North Africa (all income levels) and Natural gas rent(as % of GDP) of Malaysia?
Ensure brevity in your answer.  -0.1. In the year 1981, what is the difference between the Natural gas rent(as % of GDP) in East Asia (all income levels) and Natural gas rent(as % of GDP) in Europe(all income levels)?
Ensure brevity in your answer.  -0.22. In the year 1981, what is the difference between the Natural gas rent(as % of GDP) in East Asia (all income levels) and Natural gas rent(as % of GDP) in Middle East & North Africa (all income levels)?
Offer a terse response. -0.83. In the year 1981, what is the difference between the Natural gas rent(as % of GDP) of East Asia (all income levels) and Natural gas rent(as % of GDP) of Malaysia?
Your answer should be very brief. -0.65. In the year 1981, what is the difference between the Natural gas rent(as % of GDP) of Europe(all income levels) and Natural gas rent(as % of GDP) of Middle East & North Africa (all income levels)?
Your answer should be very brief. -0.6. In the year 1981, what is the difference between the Natural gas rent(as % of GDP) in Europe(all income levels) and Natural gas rent(as % of GDP) in Malaysia?
Provide a short and direct response. -0.43. In the year 1981, what is the difference between the Natural gas rent(as % of GDP) of Middle East & North Africa (all income levels) and Natural gas rent(as % of GDP) of Malaysia?
Your answer should be very brief. 0.18. In the year 1982, what is the difference between the Natural gas rent(as % of GDP) in East Asia (all income levels) and Natural gas rent(as % of GDP) in Europe(all income levels)?
Offer a very short reply. -0.19. In the year 1982, what is the difference between the Natural gas rent(as % of GDP) in East Asia (all income levels) and Natural gas rent(as % of GDP) in Middle East & North Africa (all income levels)?
Offer a very short reply. -1.01. In the year 1982, what is the difference between the Natural gas rent(as % of GDP) of East Asia (all income levels) and Natural gas rent(as % of GDP) of Malaysia?
Offer a terse response. -0.81. In the year 1982, what is the difference between the Natural gas rent(as % of GDP) in Europe(all income levels) and Natural gas rent(as % of GDP) in Middle East & North Africa (all income levels)?
Offer a very short reply. -0.82. In the year 1982, what is the difference between the Natural gas rent(as % of GDP) in Europe(all income levels) and Natural gas rent(as % of GDP) in Malaysia?
Make the answer very short. -0.62. In the year 1982, what is the difference between the Natural gas rent(as % of GDP) of Middle East & North Africa (all income levels) and Natural gas rent(as % of GDP) of Malaysia?
Provide a short and direct response. 0.19. In the year 1983, what is the difference between the Natural gas rent(as % of GDP) of East Asia (all income levels) and Natural gas rent(as % of GDP) of Europe(all income levels)?
Provide a short and direct response. -0.18. In the year 1983, what is the difference between the Natural gas rent(as % of GDP) in East Asia (all income levels) and Natural gas rent(as % of GDP) in Middle East & North Africa (all income levels)?
Provide a short and direct response. -1.08. In the year 1983, what is the difference between the Natural gas rent(as % of GDP) in East Asia (all income levels) and Natural gas rent(as % of GDP) in Malaysia?
Keep it short and to the point. -1.94. In the year 1983, what is the difference between the Natural gas rent(as % of GDP) in Europe(all income levels) and Natural gas rent(as % of GDP) in Middle East & North Africa (all income levels)?
Your answer should be very brief. -0.9. In the year 1983, what is the difference between the Natural gas rent(as % of GDP) of Europe(all income levels) and Natural gas rent(as % of GDP) of Malaysia?
Ensure brevity in your answer.  -1.76. In the year 1983, what is the difference between the Natural gas rent(as % of GDP) in Middle East & North Africa (all income levels) and Natural gas rent(as % of GDP) in Malaysia?
Make the answer very short. -0.86. What is the ratio of the Natural gas rent(as % of GDP) of East Asia (all income levels) in 1976 to that in 1977?
Give a very brief answer. 0.85. What is the ratio of the Natural gas rent(as % of GDP) of Europe(all income levels) in 1976 to that in 1977?
Ensure brevity in your answer.  1. What is the ratio of the Natural gas rent(as % of GDP) of Middle East & North Africa (all income levels) in 1976 to that in 1977?
Your response must be concise. 0.95. What is the ratio of the Natural gas rent(as % of GDP) of Malaysia in 1976 to that in 1977?
Give a very brief answer. 1.16. What is the ratio of the Natural gas rent(as % of GDP) in East Asia (all income levels) in 1976 to that in 1978?
Give a very brief answer. 0.7. What is the ratio of the Natural gas rent(as % of GDP) of Europe(all income levels) in 1976 to that in 1978?
Your answer should be compact. 0.95. What is the ratio of the Natural gas rent(as % of GDP) in Middle East & North Africa (all income levels) in 1976 to that in 1978?
Give a very brief answer. 0.76. What is the ratio of the Natural gas rent(as % of GDP) of Malaysia in 1976 to that in 1978?
Make the answer very short. 0.15. What is the ratio of the Natural gas rent(as % of GDP) of East Asia (all income levels) in 1976 to that in 1980?
Give a very brief answer. 0.42. What is the ratio of the Natural gas rent(as % of GDP) in Europe(all income levels) in 1976 to that in 1980?
Your answer should be very brief. 0.79. What is the ratio of the Natural gas rent(as % of GDP) of Middle East & North Africa (all income levels) in 1976 to that in 1980?
Your response must be concise. 0.59. What is the ratio of the Natural gas rent(as % of GDP) in Malaysia in 1976 to that in 1980?
Offer a very short reply. 0.12. What is the ratio of the Natural gas rent(as % of GDP) of East Asia (all income levels) in 1976 to that in 1981?
Your answer should be compact. 0.44. What is the ratio of the Natural gas rent(as % of GDP) of Europe(all income levels) in 1976 to that in 1981?
Your answer should be compact. 0.66. What is the ratio of the Natural gas rent(as % of GDP) in Middle East & North Africa (all income levels) in 1976 to that in 1981?
Provide a short and direct response. 0.49. What is the ratio of the Natural gas rent(as % of GDP) of Malaysia in 1976 to that in 1981?
Offer a terse response. 0.13. What is the ratio of the Natural gas rent(as % of GDP) in East Asia (all income levels) in 1976 to that in 1982?
Offer a very short reply. 0.42. What is the ratio of the Natural gas rent(as % of GDP) of Europe(all income levels) in 1976 to that in 1982?
Offer a terse response. 0.68. What is the ratio of the Natural gas rent(as % of GDP) of Middle East & North Africa (all income levels) in 1976 to that in 1982?
Your answer should be compact. 0.42. What is the ratio of the Natural gas rent(as % of GDP) of Malaysia in 1976 to that in 1982?
Ensure brevity in your answer.  0.11. What is the ratio of the Natural gas rent(as % of GDP) in East Asia (all income levels) in 1976 to that in 1983?
Ensure brevity in your answer.  0.42. What is the ratio of the Natural gas rent(as % of GDP) of Europe(all income levels) in 1976 to that in 1983?
Offer a very short reply. 0.69. What is the ratio of the Natural gas rent(as % of GDP) of Middle East & North Africa (all income levels) in 1976 to that in 1983?
Your response must be concise. 0.4. What is the ratio of the Natural gas rent(as % of GDP) in Malaysia in 1976 to that in 1983?
Make the answer very short. 0.05. What is the ratio of the Natural gas rent(as % of GDP) in East Asia (all income levels) in 1977 to that in 1978?
Provide a short and direct response. 0.83. What is the ratio of the Natural gas rent(as % of GDP) of Europe(all income levels) in 1977 to that in 1978?
Make the answer very short. 0.95. What is the ratio of the Natural gas rent(as % of GDP) of Middle East & North Africa (all income levels) in 1977 to that in 1978?
Give a very brief answer. 0.81. What is the ratio of the Natural gas rent(as % of GDP) in Malaysia in 1977 to that in 1978?
Provide a short and direct response. 0.13. What is the ratio of the Natural gas rent(as % of GDP) in East Asia (all income levels) in 1977 to that in 1980?
Your answer should be compact. 0.49. What is the ratio of the Natural gas rent(as % of GDP) in Europe(all income levels) in 1977 to that in 1980?
Keep it short and to the point. 0.79. What is the ratio of the Natural gas rent(as % of GDP) in Middle East & North Africa (all income levels) in 1977 to that in 1980?
Provide a short and direct response. 0.63. What is the ratio of the Natural gas rent(as % of GDP) in Malaysia in 1977 to that in 1980?
Provide a succinct answer. 0.1. What is the ratio of the Natural gas rent(as % of GDP) of East Asia (all income levels) in 1977 to that in 1981?
Make the answer very short. 0.52. What is the ratio of the Natural gas rent(as % of GDP) of Europe(all income levels) in 1977 to that in 1981?
Provide a short and direct response. 0.66. What is the ratio of the Natural gas rent(as % of GDP) in Middle East & North Africa (all income levels) in 1977 to that in 1981?
Your answer should be very brief. 0.52. What is the ratio of the Natural gas rent(as % of GDP) in Malaysia in 1977 to that in 1981?
Your answer should be compact. 0.11. What is the ratio of the Natural gas rent(as % of GDP) in East Asia (all income levels) in 1977 to that in 1982?
Your response must be concise. 0.49. What is the ratio of the Natural gas rent(as % of GDP) of Europe(all income levels) in 1977 to that in 1982?
Your answer should be compact. 0.68. What is the ratio of the Natural gas rent(as % of GDP) in Middle East & North Africa (all income levels) in 1977 to that in 1982?
Offer a very short reply. 0.45. What is the ratio of the Natural gas rent(as % of GDP) of Malaysia in 1977 to that in 1982?
Offer a terse response. 0.09. What is the ratio of the Natural gas rent(as % of GDP) in East Asia (all income levels) in 1977 to that in 1983?
Your answer should be very brief. 0.49. What is the ratio of the Natural gas rent(as % of GDP) of Europe(all income levels) in 1977 to that in 1983?
Your answer should be very brief. 0.69. What is the ratio of the Natural gas rent(as % of GDP) of Middle East & North Africa (all income levels) in 1977 to that in 1983?
Ensure brevity in your answer.  0.42. What is the ratio of the Natural gas rent(as % of GDP) in Malaysia in 1977 to that in 1983?
Provide a short and direct response. 0.05. What is the ratio of the Natural gas rent(as % of GDP) in East Asia (all income levels) in 1978 to that in 1980?
Give a very brief answer. 0.6. What is the ratio of the Natural gas rent(as % of GDP) of Europe(all income levels) in 1978 to that in 1980?
Make the answer very short. 0.83. What is the ratio of the Natural gas rent(as % of GDP) in Middle East & North Africa (all income levels) in 1978 to that in 1980?
Offer a terse response. 0.78. What is the ratio of the Natural gas rent(as % of GDP) in Malaysia in 1978 to that in 1980?
Offer a terse response. 0.79. What is the ratio of the Natural gas rent(as % of GDP) of East Asia (all income levels) in 1978 to that in 1981?
Offer a very short reply. 0.62. What is the ratio of the Natural gas rent(as % of GDP) in Europe(all income levels) in 1978 to that in 1981?
Ensure brevity in your answer.  0.69. What is the ratio of the Natural gas rent(as % of GDP) in Middle East & North Africa (all income levels) in 1978 to that in 1981?
Your response must be concise. 0.65. What is the ratio of the Natural gas rent(as % of GDP) in Malaysia in 1978 to that in 1981?
Make the answer very short. 0.86. What is the ratio of the Natural gas rent(as % of GDP) of East Asia (all income levels) in 1978 to that in 1982?
Make the answer very short. 0.6. What is the ratio of the Natural gas rent(as % of GDP) in Europe(all income levels) in 1978 to that in 1982?
Provide a short and direct response. 0.71. What is the ratio of the Natural gas rent(as % of GDP) of Middle East & North Africa (all income levels) in 1978 to that in 1982?
Your response must be concise. 0.55. What is the ratio of the Natural gas rent(as % of GDP) of Malaysia in 1978 to that in 1982?
Offer a very short reply. 0.72. What is the ratio of the Natural gas rent(as % of GDP) of East Asia (all income levels) in 1978 to that in 1983?
Offer a terse response. 0.6. What is the ratio of the Natural gas rent(as % of GDP) of Europe(all income levels) in 1978 to that in 1983?
Keep it short and to the point. 0.72. What is the ratio of the Natural gas rent(as % of GDP) in Middle East & North Africa (all income levels) in 1978 to that in 1983?
Provide a succinct answer. 0.52. What is the ratio of the Natural gas rent(as % of GDP) in Malaysia in 1978 to that in 1983?
Your answer should be compact. 0.36. What is the ratio of the Natural gas rent(as % of GDP) in East Asia (all income levels) in 1980 to that in 1981?
Provide a short and direct response. 1.05. What is the ratio of the Natural gas rent(as % of GDP) in Europe(all income levels) in 1980 to that in 1981?
Your answer should be very brief. 0.83. What is the ratio of the Natural gas rent(as % of GDP) of Middle East & North Africa (all income levels) in 1980 to that in 1981?
Your answer should be compact. 0.83. What is the ratio of the Natural gas rent(as % of GDP) of Malaysia in 1980 to that in 1981?
Your answer should be compact. 1.1. What is the ratio of the Natural gas rent(as % of GDP) of Europe(all income levels) in 1980 to that in 1982?
Provide a succinct answer. 0.86. What is the ratio of the Natural gas rent(as % of GDP) of Middle East & North Africa (all income levels) in 1980 to that in 1982?
Offer a very short reply. 0.71. What is the ratio of the Natural gas rent(as % of GDP) of Malaysia in 1980 to that in 1982?
Your answer should be compact. 0.92. What is the ratio of the Natural gas rent(as % of GDP) in Middle East & North Africa (all income levels) in 1980 to that in 1983?
Provide a succinct answer. 0.67. What is the ratio of the Natural gas rent(as % of GDP) in Malaysia in 1980 to that in 1983?
Your answer should be very brief. 0.46. What is the ratio of the Natural gas rent(as % of GDP) in East Asia (all income levels) in 1981 to that in 1982?
Keep it short and to the point. 0.96. What is the ratio of the Natural gas rent(as % of GDP) of Europe(all income levels) in 1981 to that in 1982?
Provide a succinct answer. 1.04. What is the ratio of the Natural gas rent(as % of GDP) of Middle East & North Africa (all income levels) in 1981 to that in 1982?
Your response must be concise. 0.85. What is the ratio of the Natural gas rent(as % of GDP) of Malaysia in 1981 to that in 1982?
Ensure brevity in your answer.  0.84. What is the ratio of the Natural gas rent(as % of GDP) in East Asia (all income levels) in 1981 to that in 1983?
Offer a terse response. 0.95. What is the ratio of the Natural gas rent(as % of GDP) in Europe(all income levels) in 1981 to that in 1983?
Your answer should be compact. 1.05. What is the ratio of the Natural gas rent(as % of GDP) of Middle East & North Africa (all income levels) in 1981 to that in 1983?
Your response must be concise. 0.81. What is the ratio of the Natural gas rent(as % of GDP) in Malaysia in 1981 to that in 1983?
Give a very brief answer. 0.42. What is the ratio of the Natural gas rent(as % of GDP) in East Asia (all income levels) in 1982 to that in 1983?
Offer a very short reply. 1. What is the ratio of the Natural gas rent(as % of GDP) in Europe(all income levels) in 1982 to that in 1983?
Give a very brief answer. 1.01. What is the ratio of the Natural gas rent(as % of GDP) in Middle East & North Africa (all income levels) in 1982 to that in 1983?
Your answer should be very brief. 0.94. What is the ratio of the Natural gas rent(as % of GDP) of Malaysia in 1982 to that in 1983?
Keep it short and to the point. 0.5. What is the difference between the highest and the second highest Natural gas rent(as % of GDP) of East Asia (all income levels)?
Keep it short and to the point. 0. What is the difference between the highest and the second highest Natural gas rent(as % of GDP) in Europe(all income levels)?
Keep it short and to the point. 0.02. What is the difference between the highest and the second highest Natural gas rent(as % of GDP) of Middle East & North Africa (all income levels)?
Make the answer very short. 0.08. What is the difference between the highest and the second highest Natural gas rent(as % of GDP) of Malaysia?
Give a very brief answer. 1.13. What is the difference between the highest and the lowest Natural gas rent(as % of GDP) in East Asia (all income levels)?
Offer a very short reply. 0.18. What is the difference between the highest and the lowest Natural gas rent(as % of GDP) of Europe(all income levels)?
Provide a succinct answer. 0.18. What is the difference between the highest and the lowest Natural gas rent(as % of GDP) in Middle East & North Africa (all income levels)?
Your response must be concise. 0.84. What is the difference between the highest and the lowest Natural gas rent(as % of GDP) in Malaysia?
Keep it short and to the point. 2.15. 